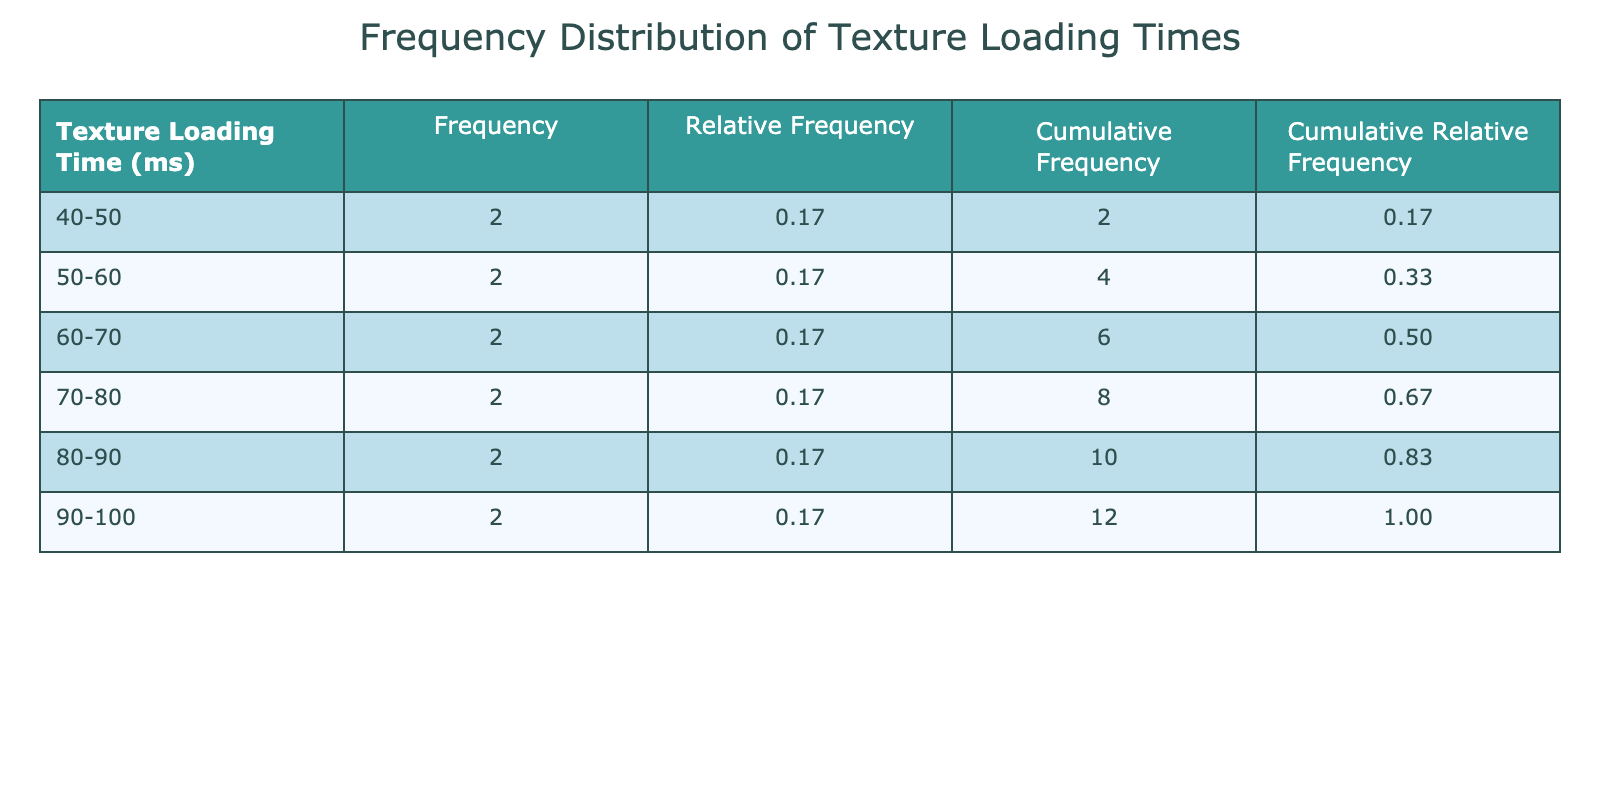What is the frequency of texture loading times in the 50-60 ms bin? To find the frequency in the 50-60 ms bin, I look at the frequency column corresponding to the bin labeled "50-60". According to the table, the frequency for this bin is 2.
Answer: 2 Which level has the longest texture loading time? To determine which level has the longest texture loading time, I need to check the values listed for each level in the table. The level with the highest loading time is "Swamp of Despair" at 100 ms.
Answer: Swamp of Despair What is the cumulative frequency for the 70-80 ms bin? The cumulative frequency for the 70-80 ms bin is the sum of the frequency values from the start up to that bin. I identify the frequencies: 0 (40-50), 1 (50-60), 1 (60-70), and 3 (70-80), which gives: 0 + 1 + 1 + 3 = 5.
Answer: 5 Is the relative frequency of the 40-50 ms bin greater than 0.20? To check this, I locate the relative frequency for the 40-50 ms bin in the relevant column. It is calculated as frequency / total number of levels, which is 1/10 = 0.10. Since 0.10 is not greater than 0.20, the answer is no.
Answer: No What is the average texture loading time across all levels? To find the average loading time, I first sum all the loading times. The total is (45 + 70 + 90 + 55 + 80 + 100 + 65 + 75 + 50 + 40 + 85 + 60) = 1050 ms. Since there are 12 levels, the average is 1050 / 12 = 87.5 ms.
Answer: 87.5 ms How many levels have a texture loading time of 80 ms or more? I need to look at the loading times and count the levels that fall into the category of 80 ms or more. The levels meeting this criterion are "Frozen Tundra", "Swamp of Despair", "Crystal Caves", so the count is 3.
Answer: 3 What percentage of levels have a loading time between 60 ms and 70 ms? First, I find the frequency for the 60-70 ms bin, which is 1. There are 12 levels in total. The percentage is calculated as (1 / 12) * 100 = 8.33%.
Answer: 8.33% Which bin contains the highest frequency of texture loading times? To find the bin with the highest frequency, I reference the frequency column and look for the maximum value among the rows. The highest frequency is located in the "70-80" bin, which has a frequency of 3.
Answer: 70-80 ms What is the cumulative relative frequency for the 80-90 ms bin? The cumulative relative frequency for the 80-90 ms bin is the sum of the relative frequencies from all previous bins up to and including the 80-90 bin. Adding up the relevant relative frequencies gives: 0.10 (40-50) + 0.10 (50-60) + 0.10 (60-70) + 0.20 (70-80) + 0.10 (80-90) = 0.60.
Answer: 0.60 